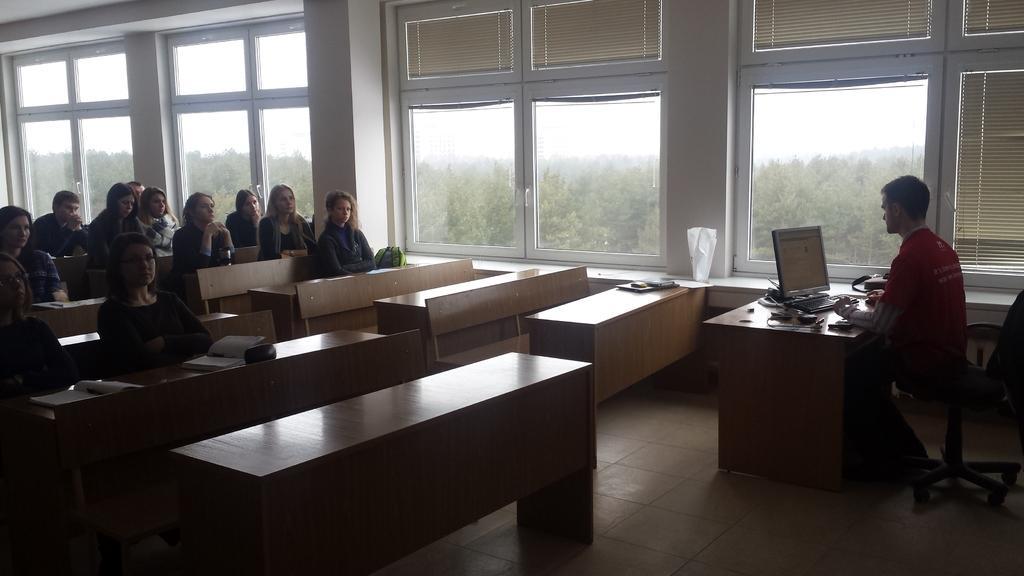Please provide a concise description of this image. In this image there are group of persons sitting. On the right side there is a person sitting and looking at the monitor which is in front of him. On the table there is a monitor, keyboard, and there are wires. In the center there are windows and behind the windows there are trees. In the front there are empty benches. 